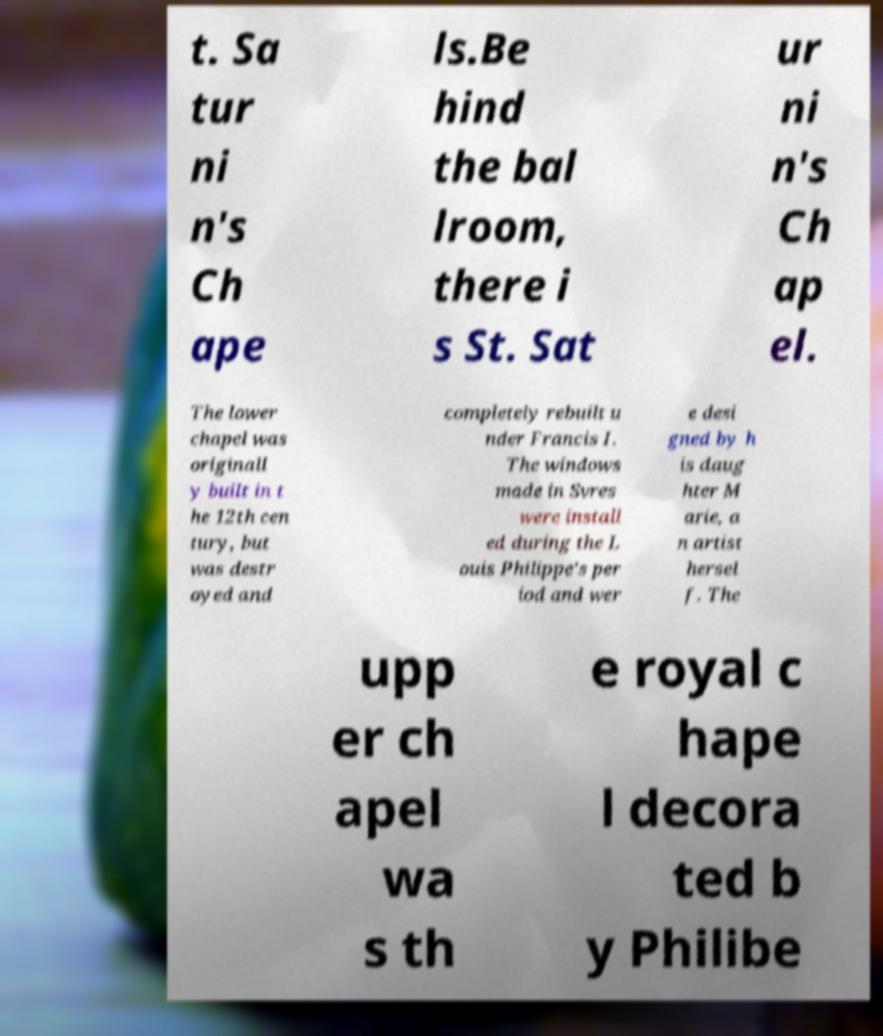Could you extract and type out the text from this image? t. Sa tur ni n's Ch ape ls.Be hind the bal lroom, there i s St. Sat ur ni n's Ch ap el. The lower chapel was originall y built in t he 12th cen tury, but was destr oyed and completely rebuilt u nder Francis I. The windows made in Svres were install ed during the L ouis Philippe's per iod and wer e desi gned by h is daug hter M arie, a n artist hersel f. The upp er ch apel wa s th e royal c hape l decora ted b y Philibe 